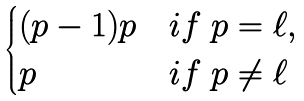Convert formula to latex. <formula><loc_0><loc_0><loc_500><loc_500>\begin{cases} ( p - 1 ) p & i f \ p = \ell , \\ p & i f \ p \neq \ell \end{cases}</formula> 